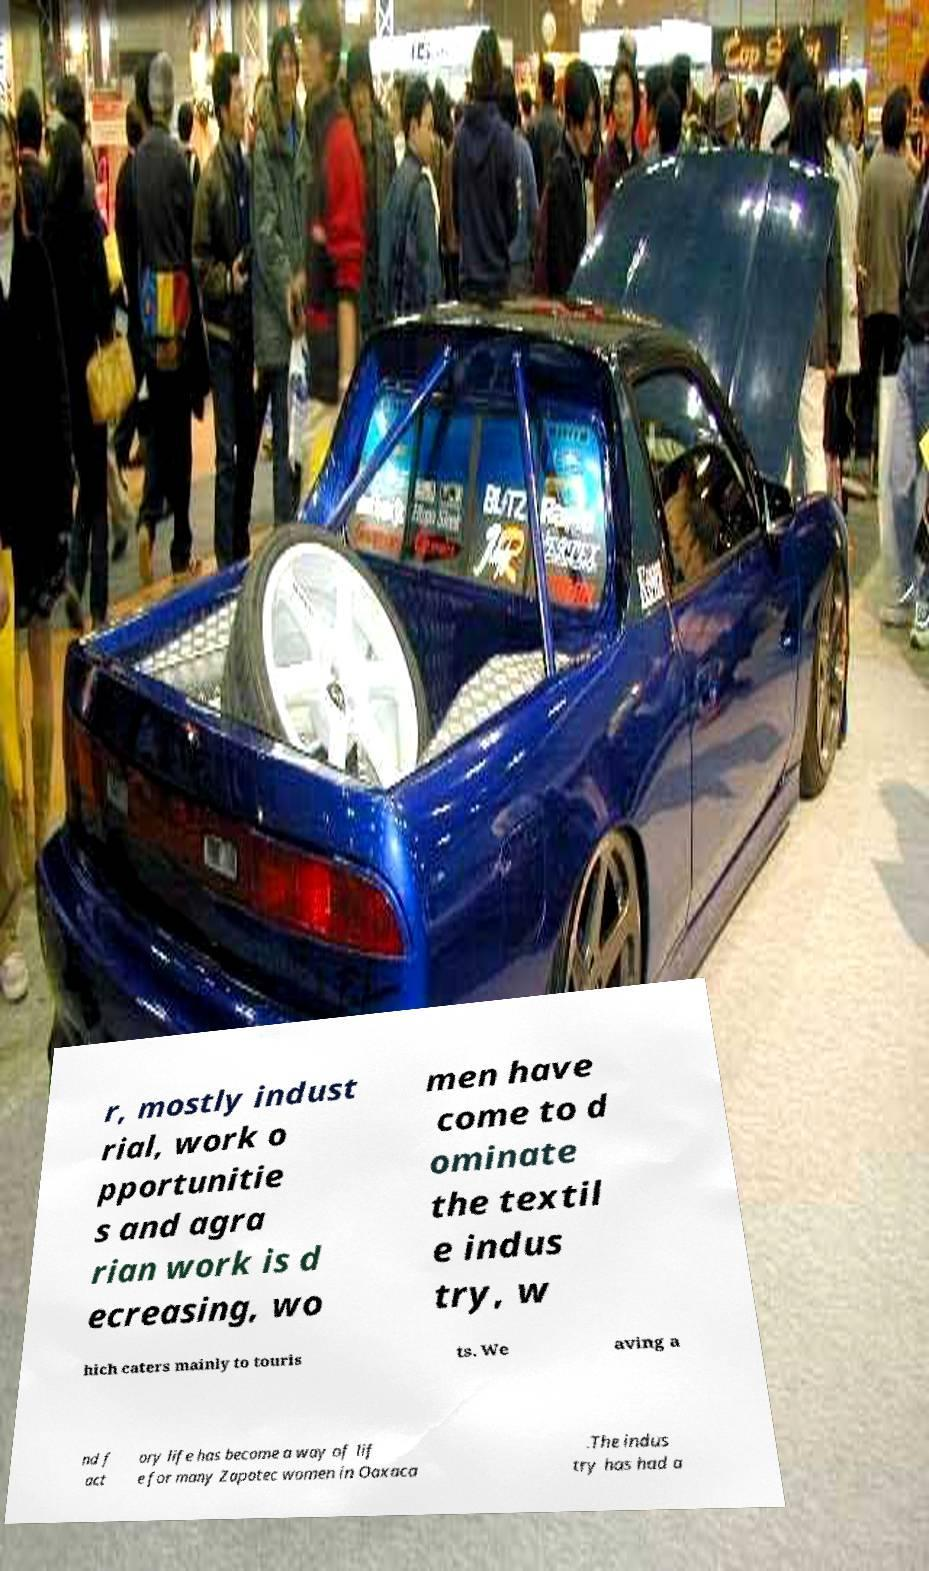What messages or text are displayed in this image? I need them in a readable, typed format. r, mostly indust rial, work o pportunitie s and agra rian work is d ecreasing, wo men have come to d ominate the textil e indus try, w hich caters mainly to touris ts. We aving a nd f act ory life has become a way of lif e for many Zapotec women in Oaxaca .The indus try has had a 